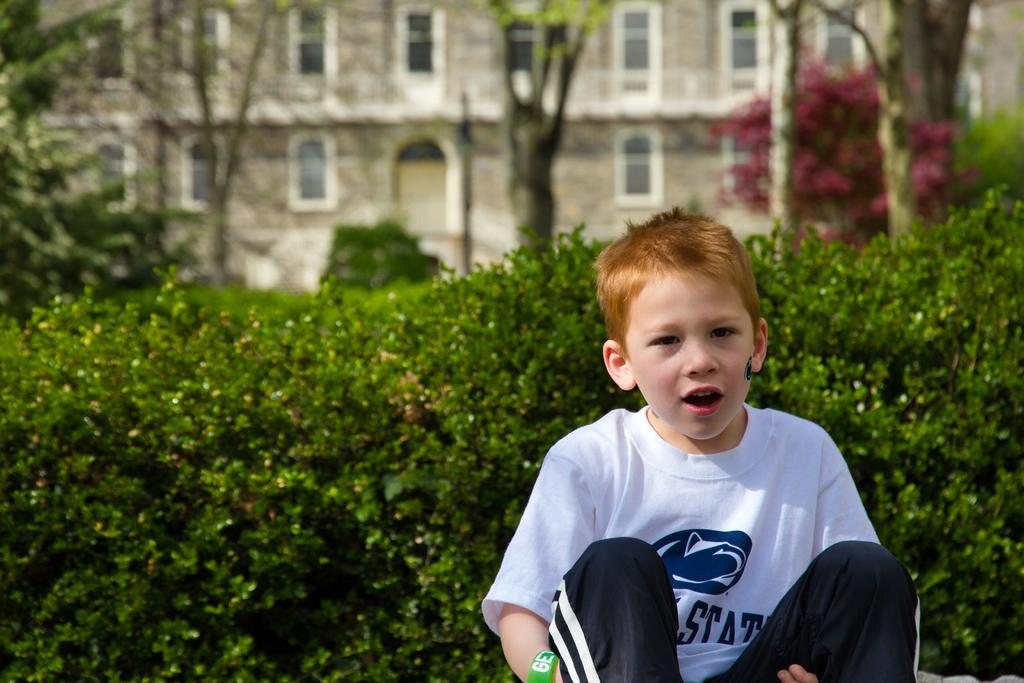<image>
Present a compact description of the photo's key features. Young boy sitting in front of bushes with a white shirt that has blue lettering Stat. 